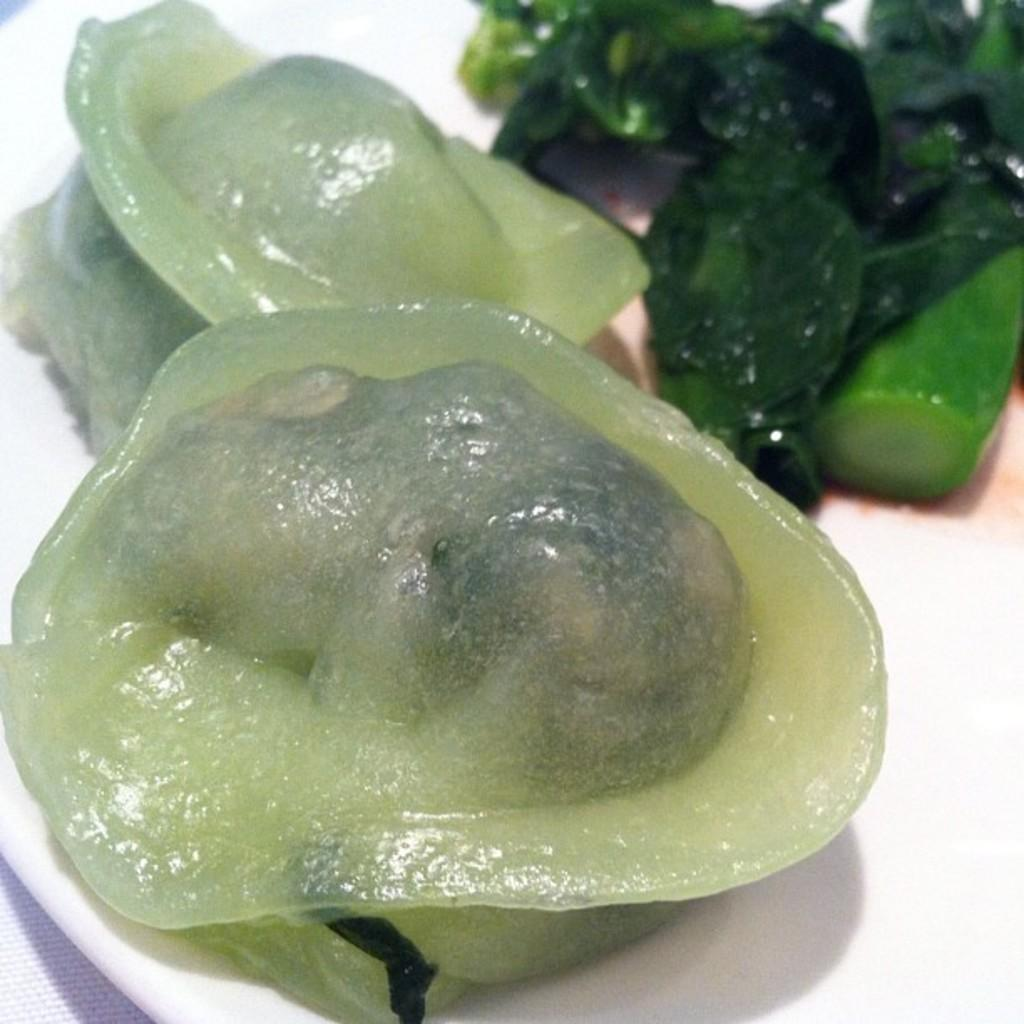What type of food can be seen in the image? There is seafood in the image. What else is present on the plate with the seafood? There are vegetables in the image. Where might the plate be located? The plate may be on a table. What is the setting of the image? The image may have been taken in a room. What type of plane can be seen flying in the image? There is no plane visible in the image; it features seafood and vegetables on a plate. What season is depicted in the image? The image does not depict a specific season, as there are no seasonal elements present. 